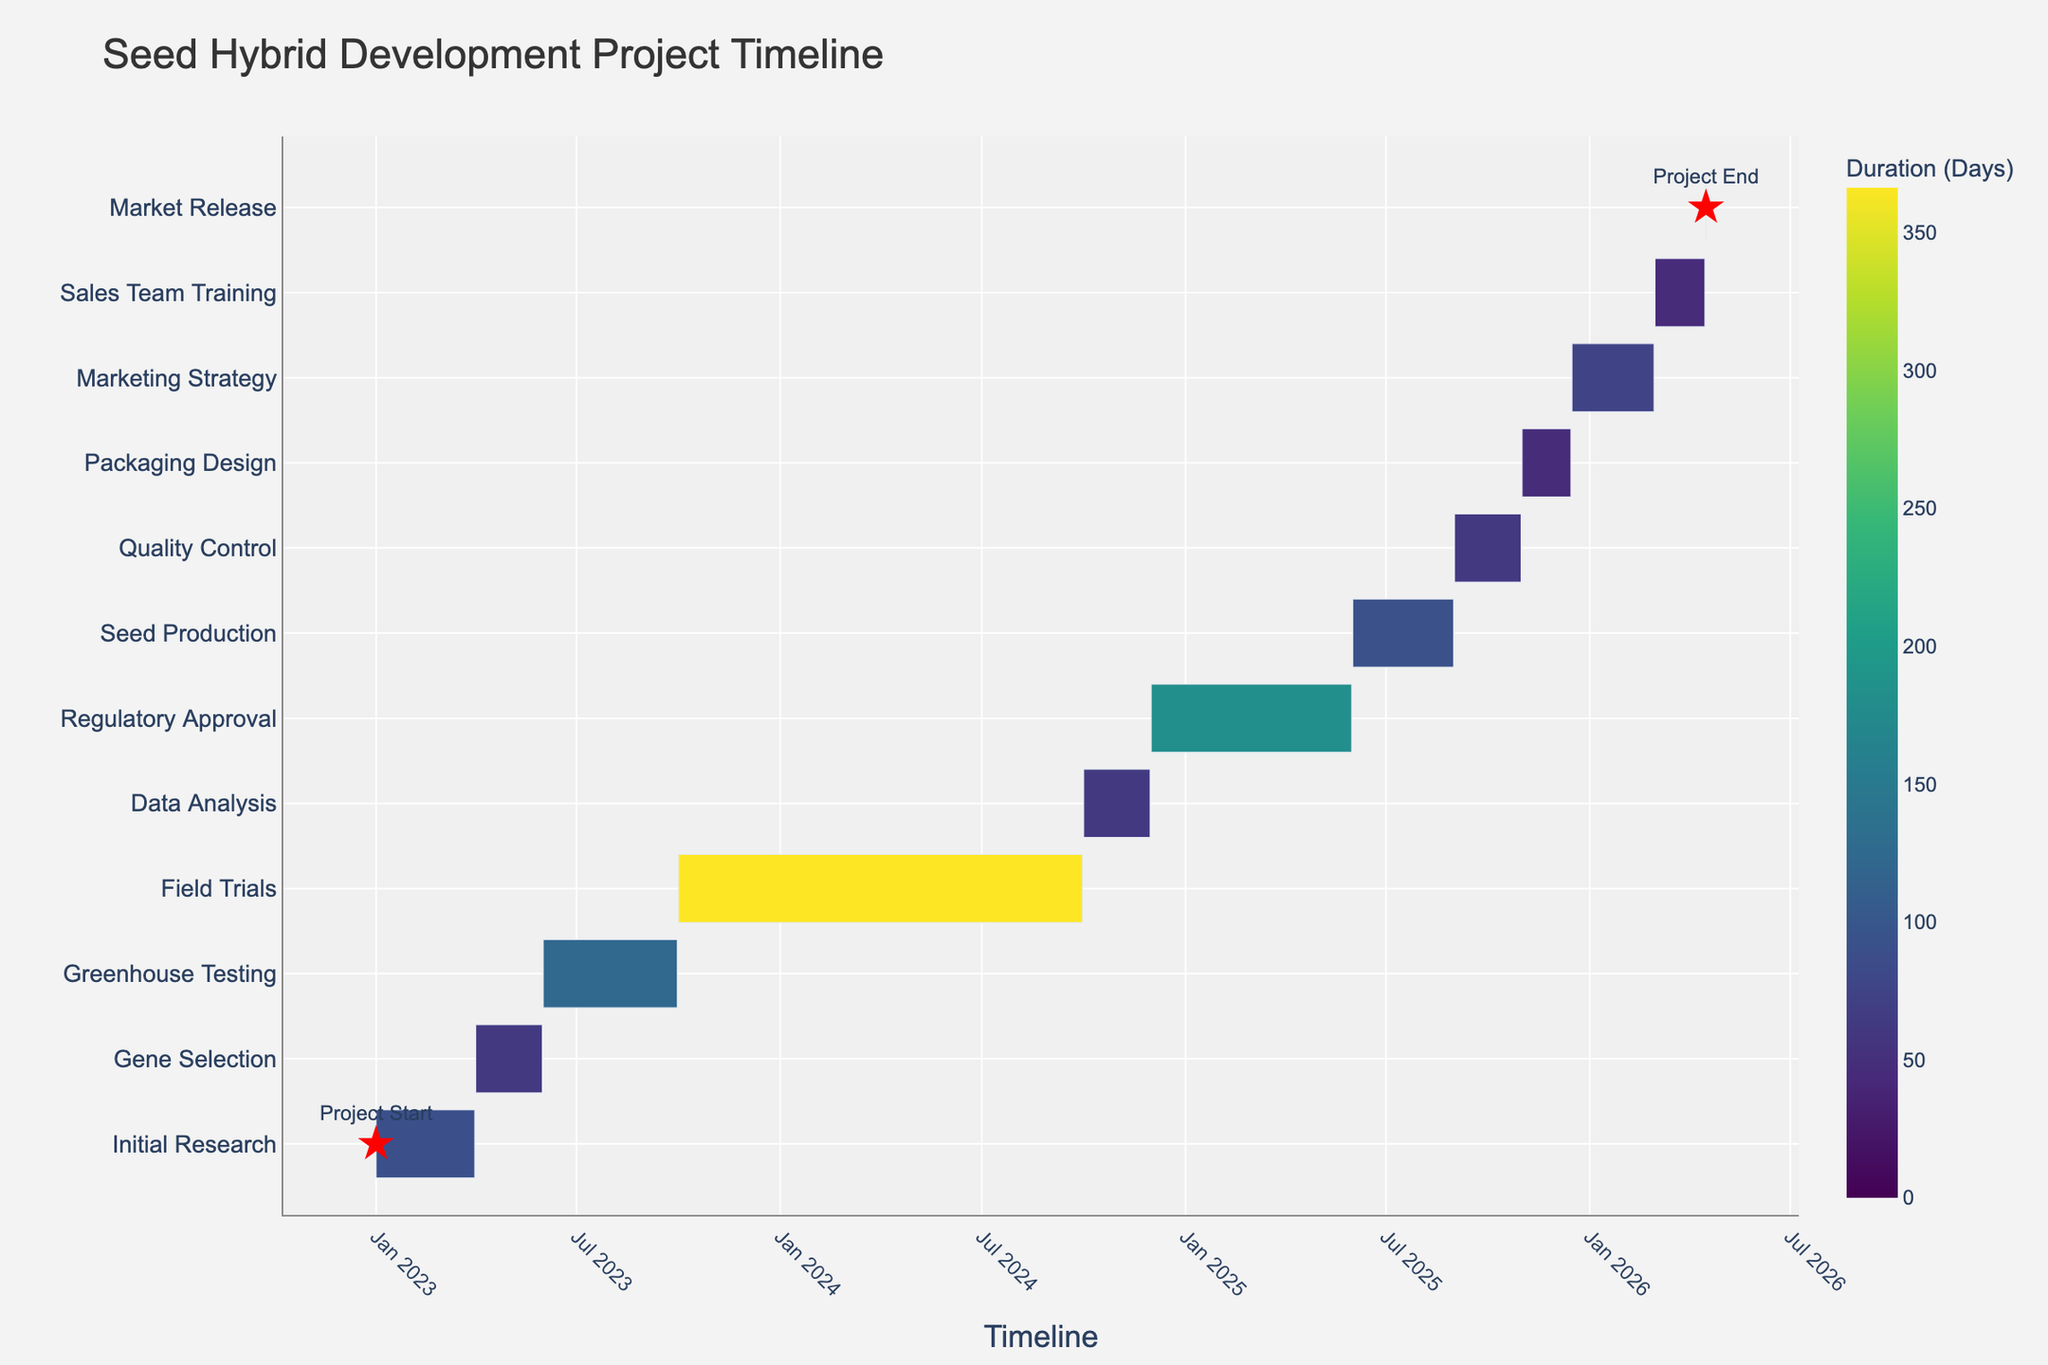What is the title of the figure? The title of the figure is usually found at the top center of the chart. In this case, it says "Seed Hybrid Development Project Timeline."
Answer: Seed Hybrid Development Project Timeline Which project phase has the longest duration? Different project phases are represented by bars of varying lengths on the Gantt chart. The longest bar corresponds to "Field Trials," indicating it has the longest duration.
Answer: Field Trials How many days does the "Data Analysis" phase last? The phase durations are depicted by different colors and labeled with the total number of days. "Data Analysis" lasts for 61 days.
Answer: 61 days Which two phases run consecutively without any gap in dates? By looking at the end date of one phase and the start date of the next, "Gene Selection" ends on 2023-05-31, and "Greenhouse Testing" starts on 2023-06-01, showing no gap.
Answer: Gene Selection and Greenhouse Testing What is the total time span from the start of "Initial Research" to the "Market Release"? The project starts with "Initial Research" on 2023-01-01 and ends on "Market Release" on 2026-04-16. Calculating the difference between these dates gives the total time span. (2026-04-16 - 2023-01-01) = 3 years, 105 days.
Answer: 3 years, 105 days Which phase comes immediately after "Field Trials"? On the chart, the phase directly following "Field Trials" is "Data Analysis," commencing right after "Field Trials."
Answer: Data Analysis Compare the duration between "Regulatory Approval" and "Seed Production." Which one lasts longer? By comparing the bars' lengths and labeled durations: "Regulatory Approval" (182 days) and "Seed Production" (92 days). The longer duration is for "Regulatory Approval."
Answer: Regulatory Approval What is the color indication for "Greenhouse Testing" duration? Each phase is color-coded based on length. The provided color scale indicates colors corresponding to the number of days. "Greenhouse Testing" with 122 days is marked with a color based on the Viridis scale.
Answer: Color based on 122 days If "Initial Research" were to be extended by 30 days, how would this affect the overall project timeline? Extending "Initial Research" affects the start of subsequent tasks. "Gene Selection" would delay by 30 days, similarly affecting each subsequent phase, and thereby extending the entire project end date by 30 days.
Answer: Project End delayed by 30 days What milestones are marked on the Gantt chart? Milestones are marked with red star symbols on the figure. The chart has two milestones: "Project Start" on 2023-01-01 and "Project End" on 2026-04-16.
Answer: Project Start, Project End 